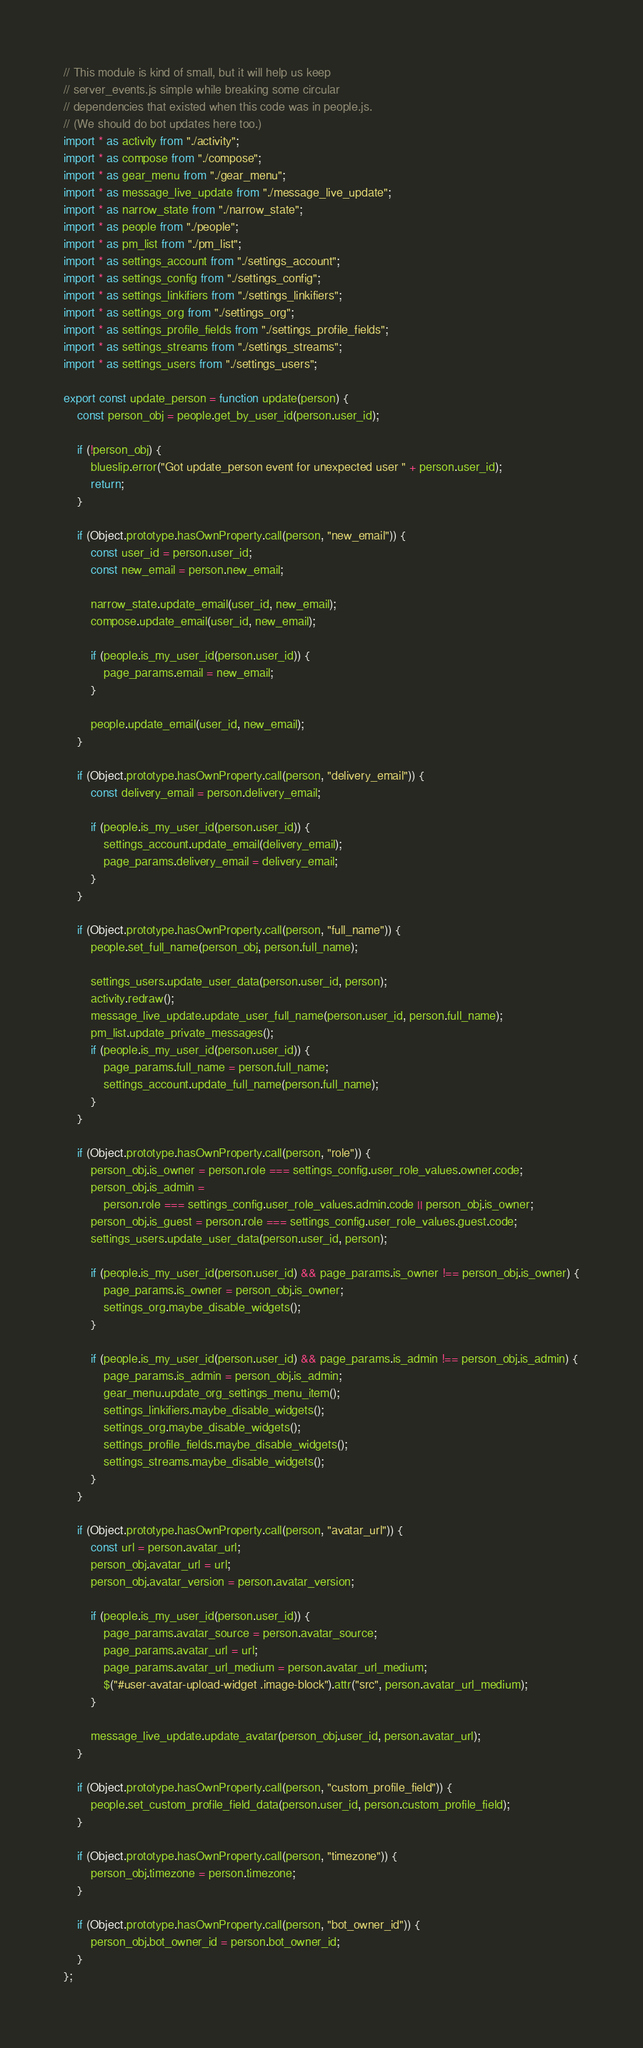<code> <loc_0><loc_0><loc_500><loc_500><_JavaScript_>// This module is kind of small, but it will help us keep
// server_events.js simple while breaking some circular
// dependencies that existed when this code was in people.js.
// (We should do bot updates here too.)
import * as activity from "./activity";
import * as compose from "./compose";
import * as gear_menu from "./gear_menu";
import * as message_live_update from "./message_live_update";
import * as narrow_state from "./narrow_state";
import * as people from "./people";
import * as pm_list from "./pm_list";
import * as settings_account from "./settings_account";
import * as settings_config from "./settings_config";
import * as settings_linkifiers from "./settings_linkifiers";
import * as settings_org from "./settings_org";
import * as settings_profile_fields from "./settings_profile_fields";
import * as settings_streams from "./settings_streams";
import * as settings_users from "./settings_users";

export const update_person = function update(person) {
    const person_obj = people.get_by_user_id(person.user_id);

    if (!person_obj) {
        blueslip.error("Got update_person event for unexpected user " + person.user_id);
        return;
    }

    if (Object.prototype.hasOwnProperty.call(person, "new_email")) {
        const user_id = person.user_id;
        const new_email = person.new_email;

        narrow_state.update_email(user_id, new_email);
        compose.update_email(user_id, new_email);

        if (people.is_my_user_id(person.user_id)) {
            page_params.email = new_email;
        }

        people.update_email(user_id, new_email);
    }

    if (Object.prototype.hasOwnProperty.call(person, "delivery_email")) {
        const delivery_email = person.delivery_email;

        if (people.is_my_user_id(person.user_id)) {
            settings_account.update_email(delivery_email);
            page_params.delivery_email = delivery_email;
        }
    }

    if (Object.prototype.hasOwnProperty.call(person, "full_name")) {
        people.set_full_name(person_obj, person.full_name);

        settings_users.update_user_data(person.user_id, person);
        activity.redraw();
        message_live_update.update_user_full_name(person.user_id, person.full_name);
        pm_list.update_private_messages();
        if (people.is_my_user_id(person.user_id)) {
            page_params.full_name = person.full_name;
            settings_account.update_full_name(person.full_name);
        }
    }

    if (Object.prototype.hasOwnProperty.call(person, "role")) {
        person_obj.is_owner = person.role === settings_config.user_role_values.owner.code;
        person_obj.is_admin =
            person.role === settings_config.user_role_values.admin.code || person_obj.is_owner;
        person_obj.is_guest = person.role === settings_config.user_role_values.guest.code;
        settings_users.update_user_data(person.user_id, person);

        if (people.is_my_user_id(person.user_id) && page_params.is_owner !== person_obj.is_owner) {
            page_params.is_owner = person_obj.is_owner;
            settings_org.maybe_disable_widgets();
        }

        if (people.is_my_user_id(person.user_id) && page_params.is_admin !== person_obj.is_admin) {
            page_params.is_admin = person_obj.is_admin;
            gear_menu.update_org_settings_menu_item();
            settings_linkifiers.maybe_disable_widgets();
            settings_org.maybe_disable_widgets();
            settings_profile_fields.maybe_disable_widgets();
            settings_streams.maybe_disable_widgets();
        }
    }

    if (Object.prototype.hasOwnProperty.call(person, "avatar_url")) {
        const url = person.avatar_url;
        person_obj.avatar_url = url;
        person_obj.avatar_version = person.avatar_version;

        if (people.is_my_user_id(person.user_id)) {
            page_params.avatar_source = person.avatar_source;
            page_params.avatar_url = url;
            page_params.avatar_url_medium = person.avatar_url_medium;
            $("#user-avatar-upload-widget .image-block").attr("src", person.avatar_url_medium);
        }

        message_live_update.update_avatar(person_obj.user_id, person.avatar_url);
    }

    if (Object.prototype.hasOwnProperty.call(person, "custom_profile_field")) {
        people.set_custom_profile_field_data(person.user_id, person.custom_profile_field);
    }

    if (Object.prototype.hasOwnProperty.call(person, "timezone")) {
        person_obj.timezone = person.timezone;
    }

    if (Object.prototype.hasOwnProperty.call(person, "bot_owner_id")) {
        person_obj.bot_owner_id = person.bot_owner_id;
    }
};
</code> 